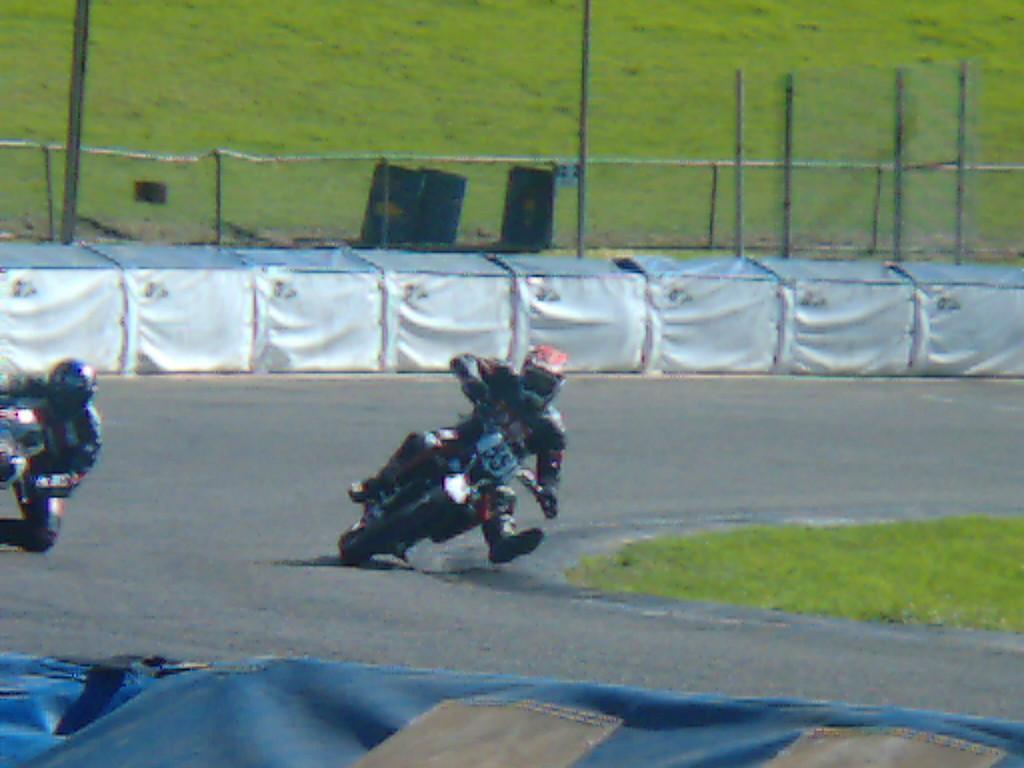Please provide a concise description of this image. Here we can see two persons riding bikes on the road. At the bottom we can see an object. In the background we can see grass,poles,fence,three drums and some other objects. 